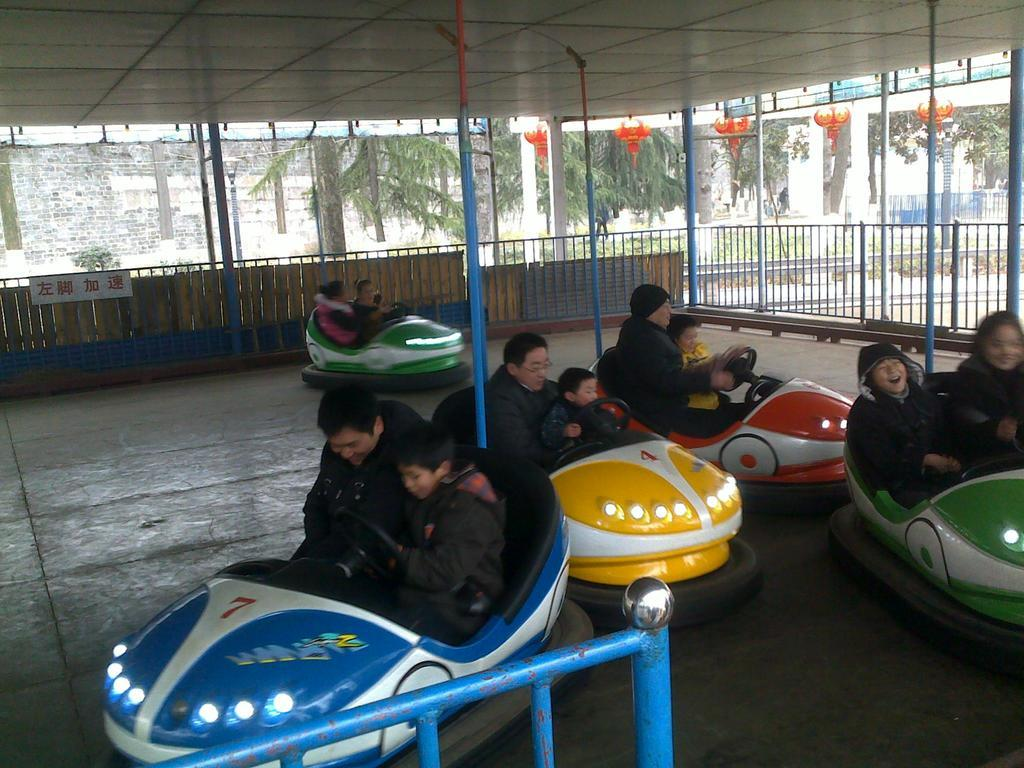How many people are in the image? There are many people in the image. What are the people wearing? The people are wearing clothes. Where are the people sitting in the image? The people are sitting in a car. What type of car is it? The car is an electric toy car. What other objects can be seen in the image? There is a pole, a fence, and trees in the image. What is the number of smiles on the people's faces in the image? The provided facts do not mention the people's facial expressions, so it is impossible to determine the number of smiles in the image. 